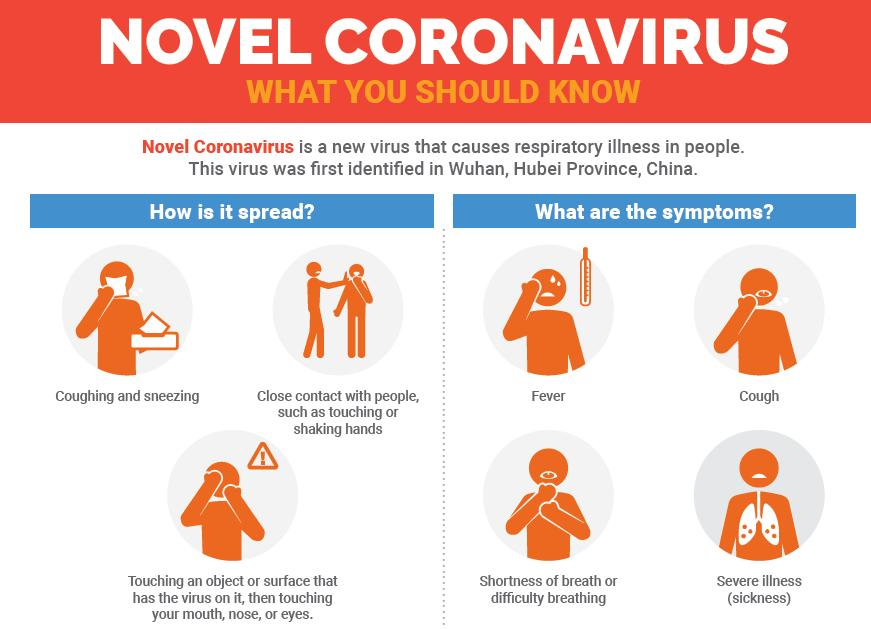Specify some key components in this picture. The symptoms of coronavirus, as listed at the top section of the graphics, are fever and cough. The symptoms of COVID-19, apart from shortness of breath, include fever, cough, and severe illness. This infographic enumerates three modes of disease transmission. The infographic provides information on 4 symptoms of the Coronavirus. The infographic states that the word "novel coronavirus" appeared two times in the content. 